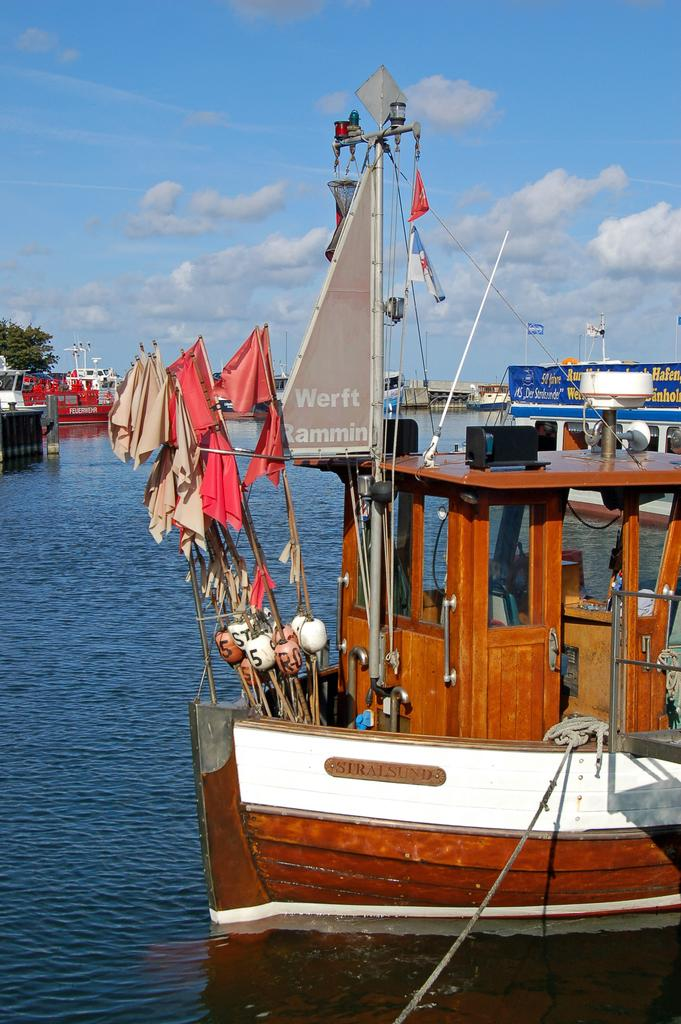<image>
Write a terse but informative summary of the picture. A boat with "Werft Ramming" on a small grey sail is docked by the shore. 